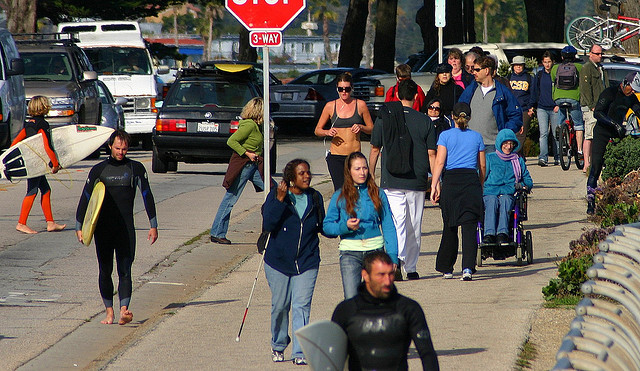Please identify all text content in this image. STOP 3 WAY 